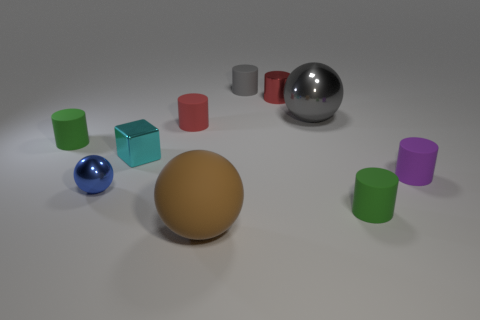Subtract 2 cylinders. How many cylinders are left? 4 Subtract all tiny gray rubber cylinders. How many cylinders are left? 5 Subtract all red cylinders. How many cylinders are left? 4 Subtract all blue cylinders. Subtract all purple blocks. How many cylinders are left? 6 Subtract all cubes. How many objects are left? 9 Subtract 1 green cylinders. How many objects are left? 9 Subtract all tiny blue objects. Subtract all cyan metal things. How many objects are left? 8 Add 8 large metal balls. How many large metal balls are left? 9 Add 3 yellow balls. How many yellow balls exist? 3 